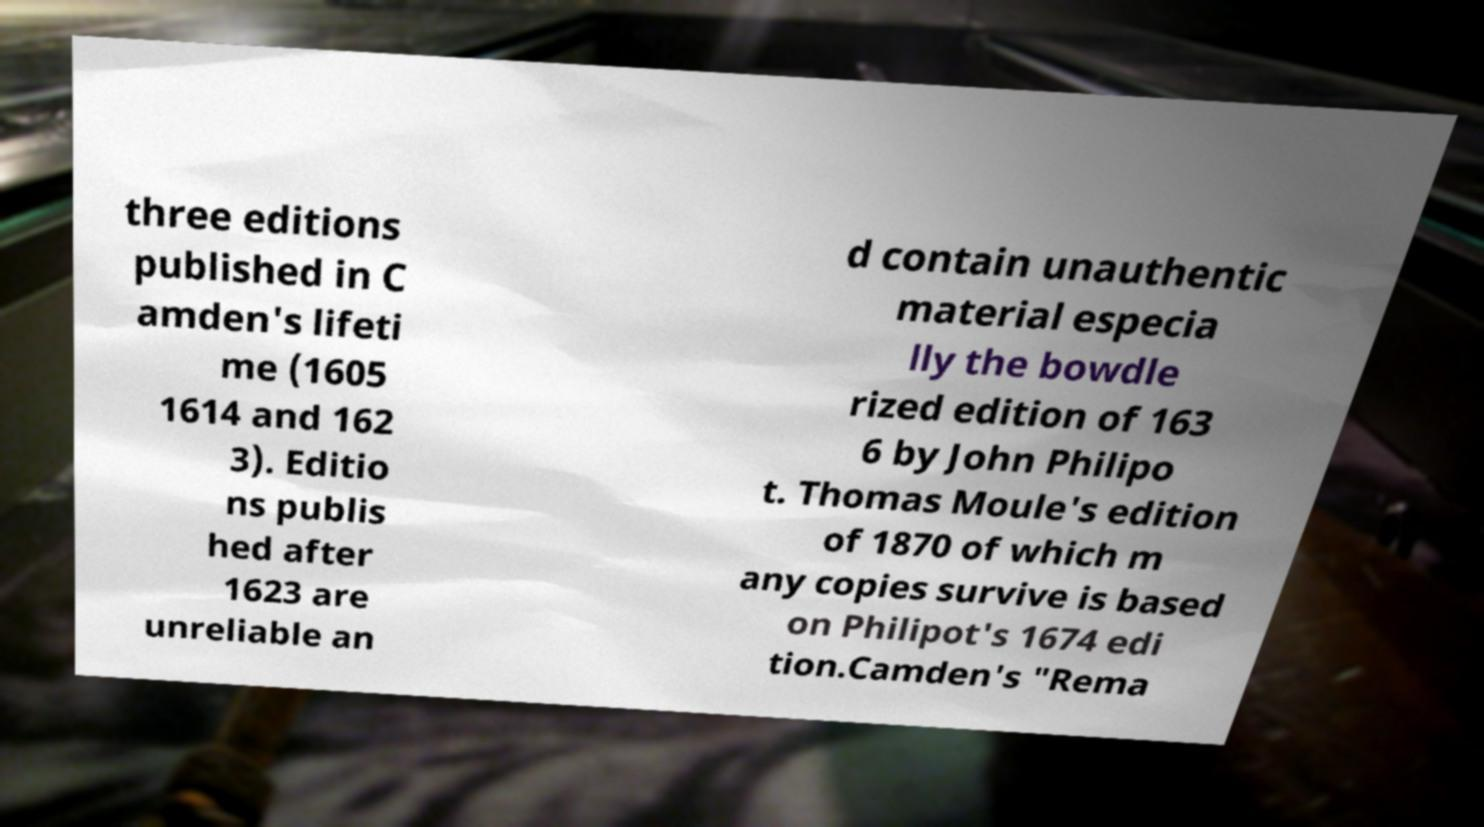I need the written content from this picture converted into text. Can you do that? three editions published in C amden's lifeti me (1605 1614 and 162 3). Editio ns publis hed after 1623 are unreliable an d contain unauthentic material especia lly the bowdle rized edition of 163 6 by John Philipo t. Thomas Moule's edition of 1870 of which m any copies survive is based on Philipot's 1674 edi tion.Camden's "Rema 